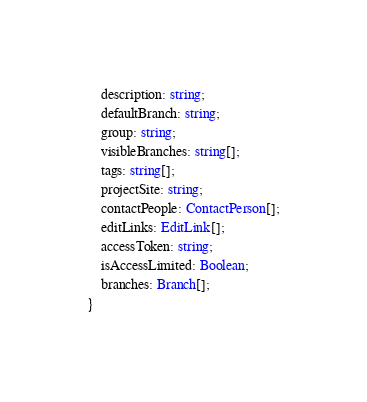<code> <loc_0><loc_0><loc_500><loc_500><_TypeScript_>    description: string;
    defaultBranch: string;
    group: string;
    visibleBranches: string[];
    tags: string[];
    projectSite: string;
    contactPeople: ContactPerson[];
    editLinks: EditLink[];
    accessToken: string;
    isAccessLimited: Boolean;
    branches: Branch[];
}</code> 